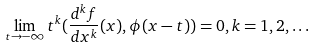Convert formula to latex. <formula><loc_0><loc_0><loc_500><loc_500>\lim _ { t \rightarrow - \infty } t ^ { k } ( \frac { d ^ { k } f } { d x ^ { k } } ( x ) , \phi ( x - t ) ) = 0 , k = 1 , 2 , \dots</formula> 